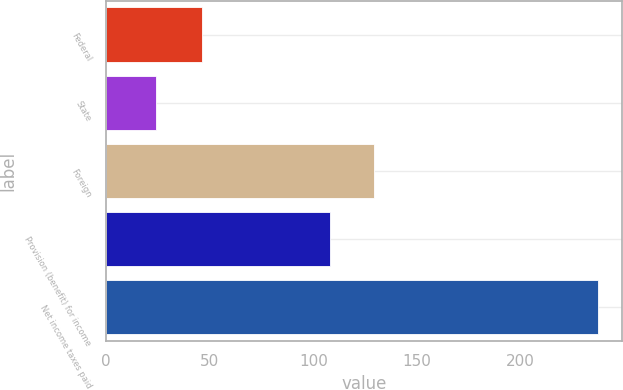<chart> <loc_0><loc_0><loc_500><loc_500><bar_chart><fcel>Federal<fcel>State<fcel>Foreign<fcel>Provision (benefit) for income<fcel>Net income taxes paid<nl><fcel>46.2<fcel>24.4<fcel>129.47<fcel>108.2<fcel>237.1<nl></chart> 